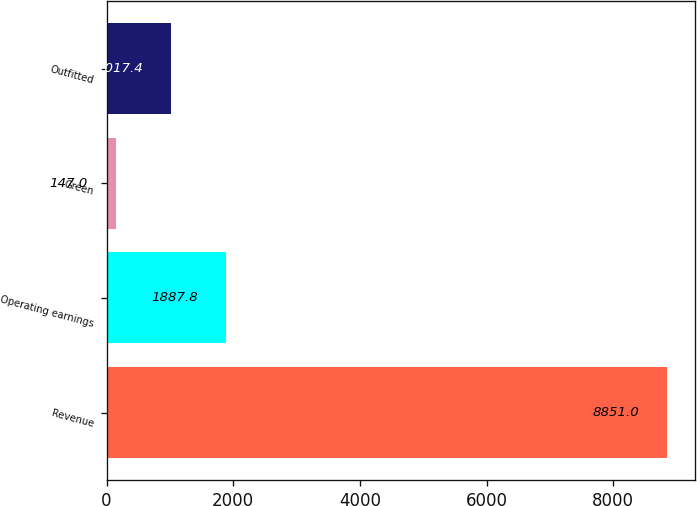Convert chart to OTSL. <chart><loc_0><loc_0><loc_500><loc_500><bar_chart><fcel>Revenue<fcel>Operating earnings<fcel>Green<fcel>Outfitted<nl><fcel>8851<fcel>1887.8<fcel>147<fcel>1017.4<nl></chart> 